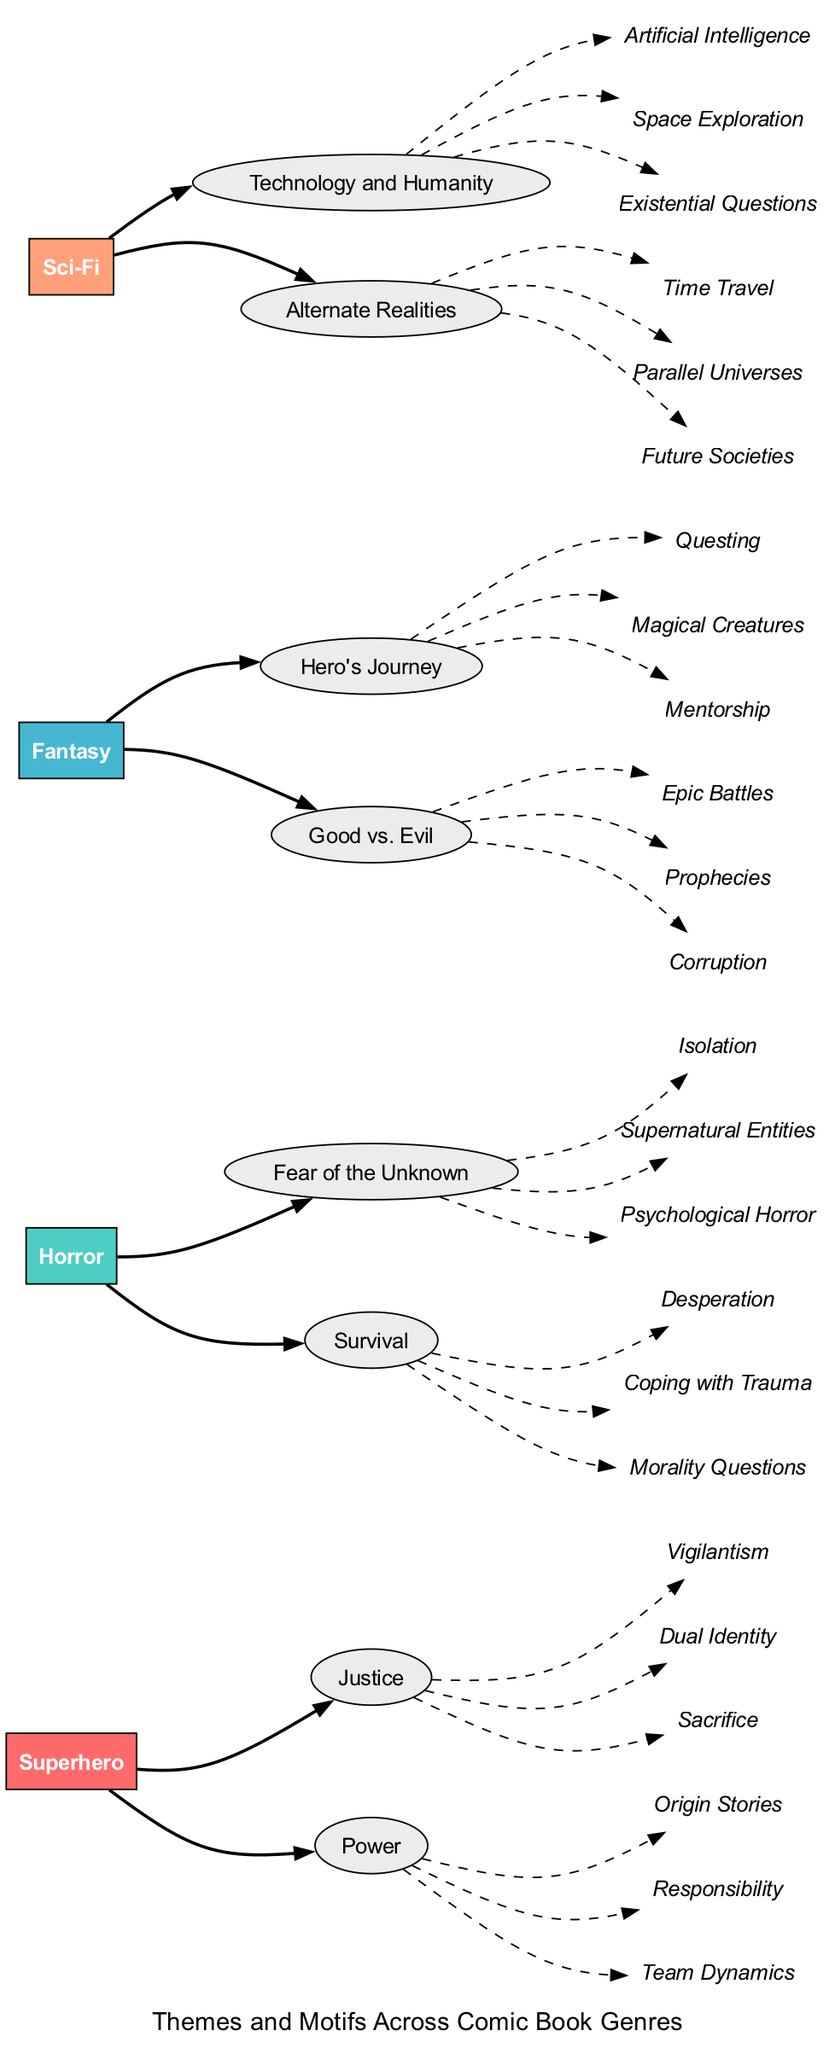What are the main genres represented in the diagram? The genres are identified as nodes at the starting points of the diagram, which are Superhero, Horror, Fantasy, and Sci-Fi.
Answer: Superhero, Horror, Fantasy, Sci-Fi How many motifs are associated with the theme of "Justice" in the Superhero genre? By examining the Superhero genre and focusing on the "Justice" theme, it is clear from the motif list that there are three motifs: Vigilantism, Dual Identity, and Sacrifice.
Answer: 3 What is the relationship between the Horror genre and "Fear of the Unknown"? The Horror genre directly connects to the "Fear of the Unknown" theme with a solid edge, indicating a direct association between the genre and this theme.
Answer: Direct association Which motif is shared between both the Fantasy and Sci-Fi genres? Looking at both genres in the diagram, only the motif of "Exploration" appears under the Sci-Fi genre related to technology, while the Fantasy genre does not include Exploration.
Answer: None How many edges are directed from the Fantasy genre? To determine the number of edges, we add the connections from the Fantasy node to its two themes: "Hero's Journey" and "Good vs. Evil," leading to a total of two edges directed from the Fantasy genre.
Answer: 2 Which genre has a motif that includes "Time Travel"? The "Time Travel" motif is found in the Sci-Fi genre under the "Alternate Realities" theme, verified by tracing the respective edges from the genre to the theme and then to the motif.
Answer: Sci-Fi What color represents the Horror genre in the diagram? The color assigned to the Horror genre is defined in the color scheme section of the diagram, which shows that it is represented in teal (#4ECDC4).
Answer: Teal How many total motifs are associated with the theme of "Survival" in the Horror genre? The Horror genre's "Survival" theme has three associated motifs: Desperation, Coping with Trauma, and Morality Questions, leading to a total of three motifs directly linked to this theme.
Answer: 3 Which theme under Sci-Fi has motifs linked with "Artificial Intelligence"? The "Technology and Humanity" theme consists of a list that includes "Artificial Intelligence," which can be linked directly through the edge from the Sci-Fi genre to this theme in the diagram.
Answer: Technology and Humanity What is the total number of themes across all comic book genres shown in the diagram? The genres and their respective themes can be counted: Superhero has 2 themes, Horror has 2 themes, Fantasy has 2 themes, and Sci-Fi has 2 themes, totaling to 8 themes across all genres.
Answer: 8 